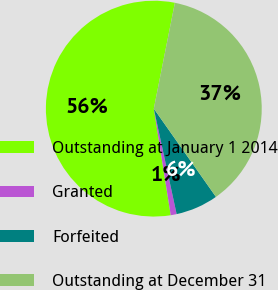Convert chart to OTSL. <chart><loc_0><loc_0><loc_500><loc_500><pie_chart><fcel>Outstanding at January 1 2014<fcel>Granted<fcel>Forfeited<fcel>Outstanding at December 31<nl><fcel>55.63%<fcel>0.89%<fcel>6.37%<fcel>37.11%<nl></chart> 